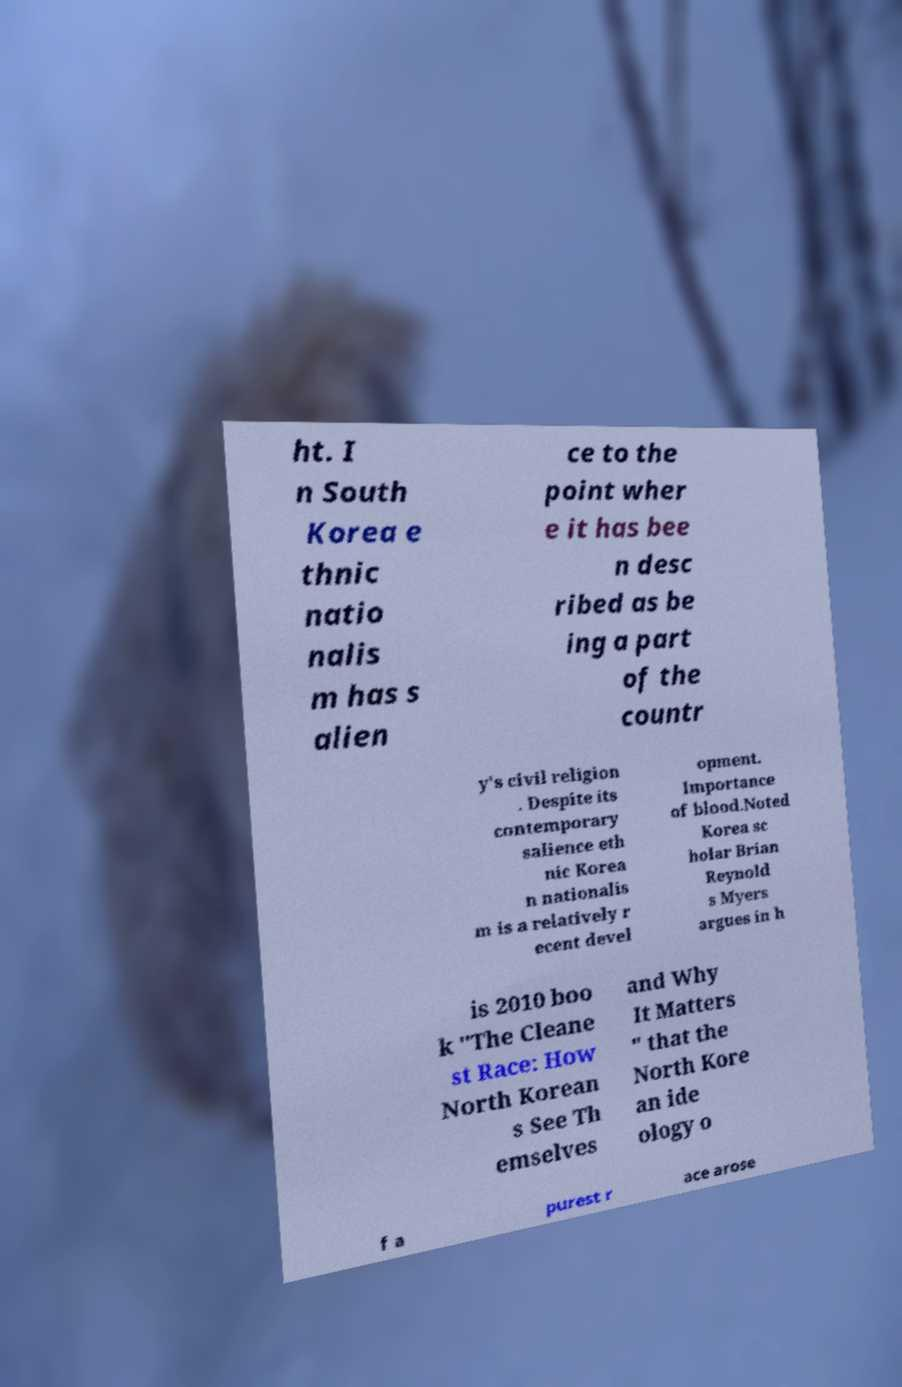For documentation purposes, I need the text within this image transcribed. Could you provide that? ht. I n South Korea e thnic natio nalis m has s alien ce to the point wher e it has bee n desc ribed as be ing a part of the countr y's civil religion . Despite its contemporary salience eth nic Korea n nationalis m is a relatively r ecent devel opment. Importance of blood.Noted Korea sc holar Brian Reynold s Myers argues in h is 2010 boo k "The Cleane st Race: How North Korean s See Th emselves and Why It Matters " that the North Kore an ide ology o f a purest r ace arose 